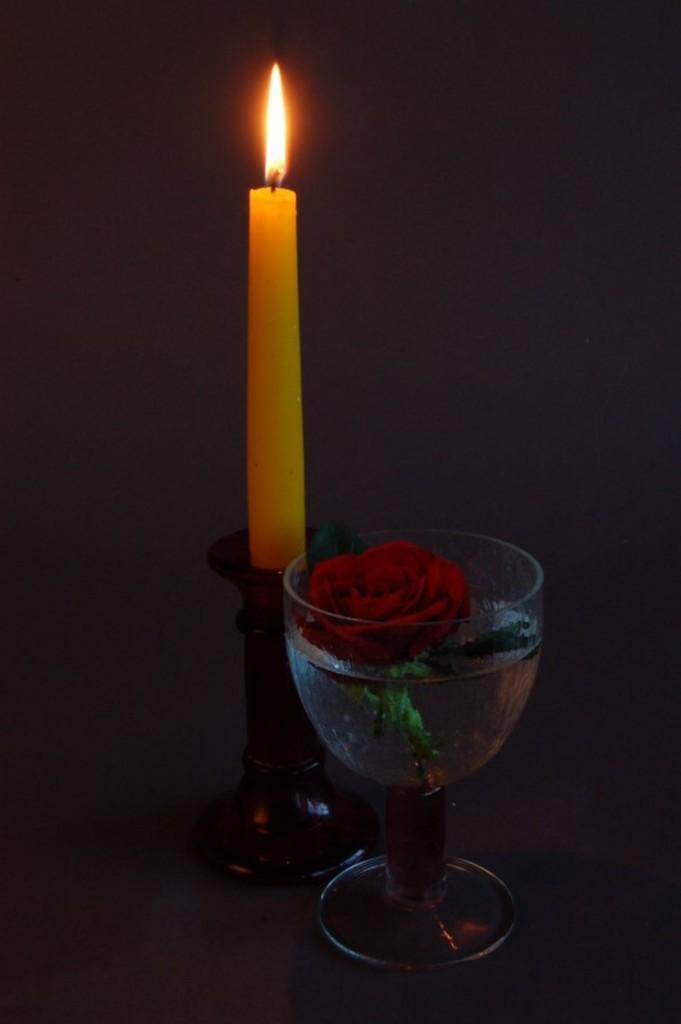Describe this image in one or two sentences. In the picture I can see a lighted candle placed on an object and there is a glass of water beside it which has a rose placed on it. 